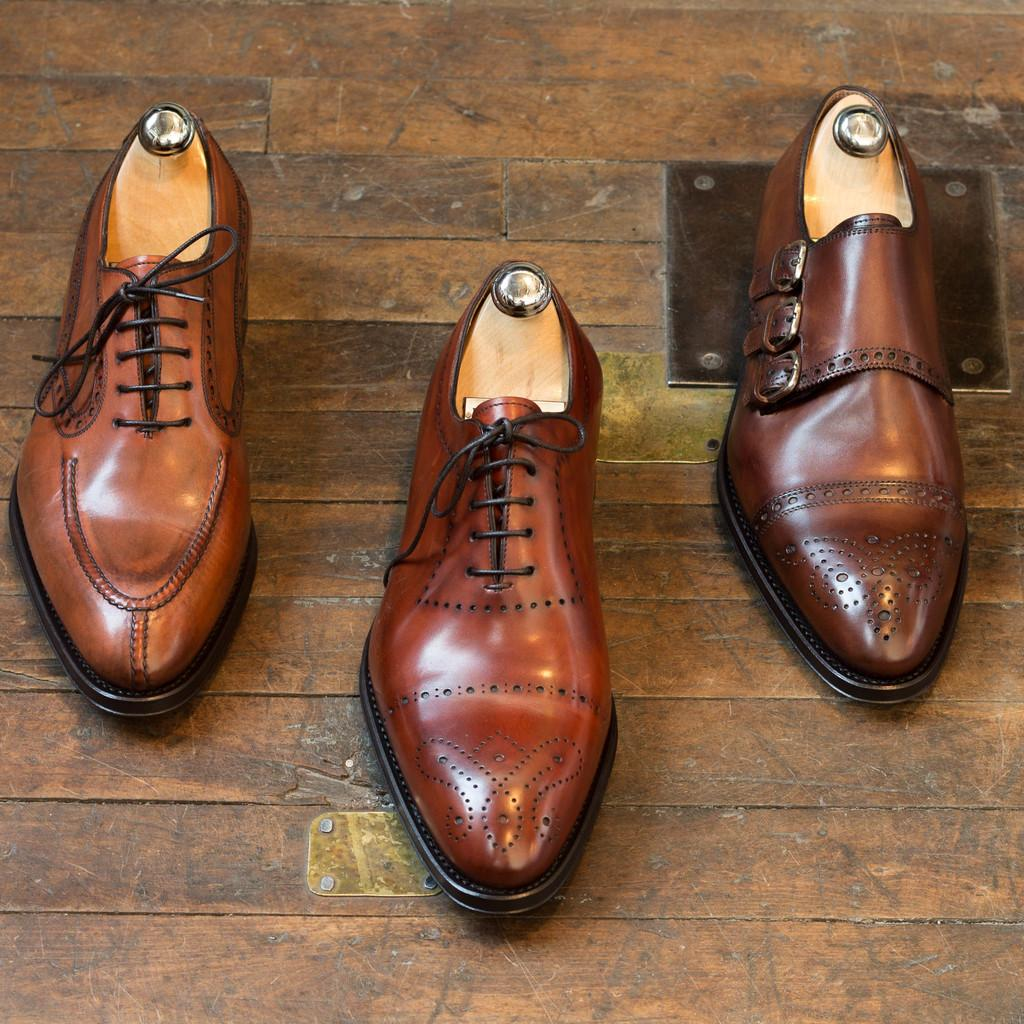How many shoes are visible in the image? There are three shoes in the image. What type of surface is the shoes placed on? The shoes are on a wooden floor. What type of gold range can be seen in the image? There is no gold range present in the image; it only features three shoes on a wooden floor. 